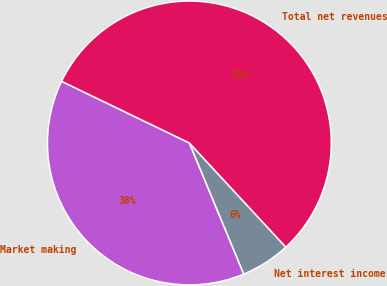<chart> <loc_0><loc_0><loc_500><loc_500><pie_chart><fcel>Market making<fcel>Net interest income<fcel>Total net revenues<nl><fcel>38.42%<fcel>5.63%<fcel>55.95%<nl></chart> 